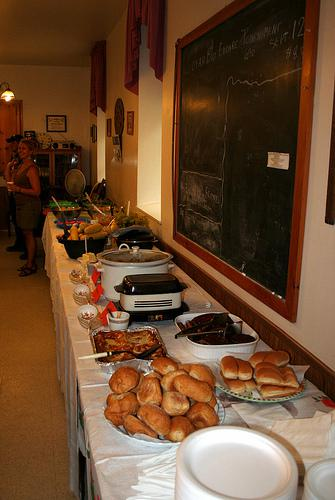Question: who is next to the table?
Choices:
A. A man.
B. A boy.
C. A woman.
D. A girl.
Answer with the letter. Answer: C Question: why is the food on the table?
Choices:
A. A buffet.
B. Thanksgiving.
C. For dinner.
D. For a picnic.
Answer with the letter. Answer: A Question: what is on the end of the table?
Choices:
A. Silverware.
B. People.
C. Chairs.
D. Plates.
Answer with the letter. Answer: D Question: where is the fan?
Choices:
A. At the end of the table.
B. On the ceiling.
C. Inside of the house.
D. Outside of the house.
Answer with the letter. Answer: A 